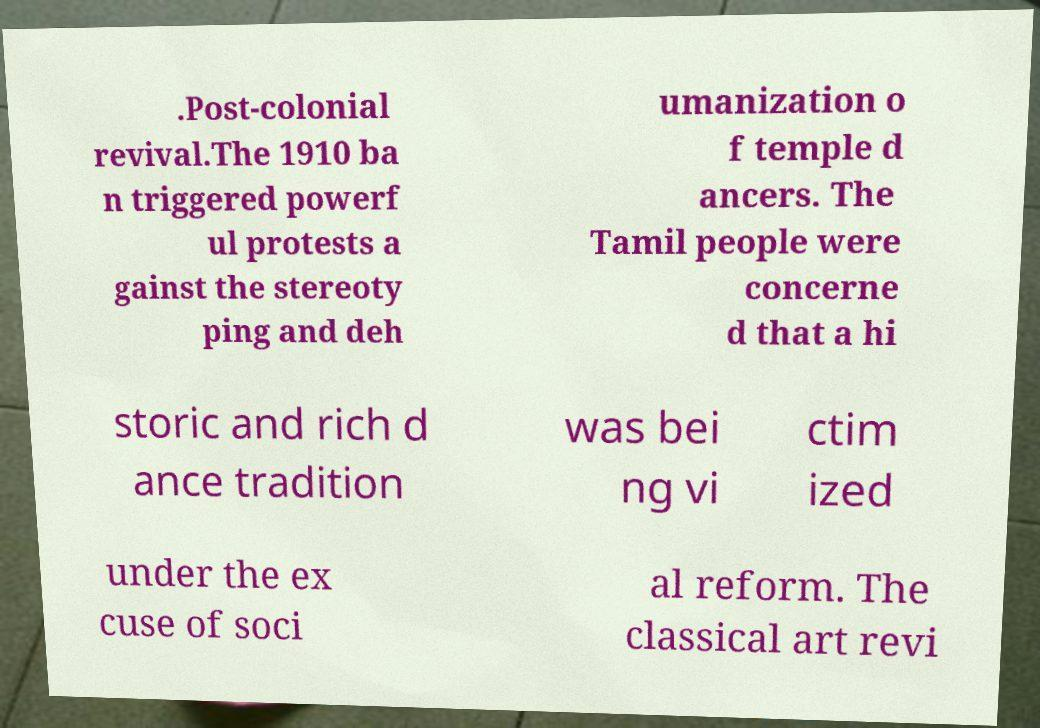I need the written content from this picture converted into text. Can you do that? .Post-colonial revival.The 1910 ba n triggered powerf ul protests a gainst the stereoty ping and deh umanization o f temple d ancers. The Tamil people were concerne d that a hi storic and rich d ance tradition was bei ng vi ctim ized under the ex cuse of soci al reform. The classical art revi 